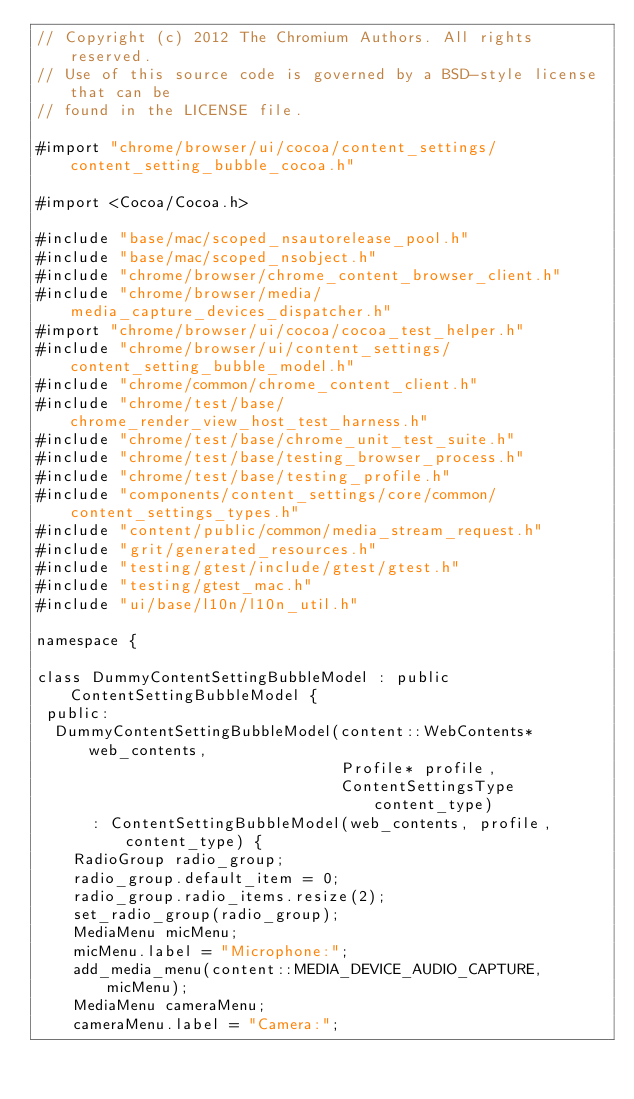<code> <loc_0><loc_0><loc_500><loc_500><_ObjectiveC_>// Copyright (c) 2012 The Chromium Authors. All rights reserved.
// Use of this source code is governed by a BSD-style license that can be
// found in the LICENSE file.

#import "chrome/browser/ui/cocoa/content_settings/content_setting_bubble_cocoa.h"

#import <Cocoa/Cocoa.h>

#include "base/mac/scoped_nsautorelease_pool.h"
#include "base/mac/scoped_nsobject.h"
#include "chrome/browser/chrome_content_browser_client.h"
#include "chrome/browser/media/media_capture_devices_dispatcher.h"
#import "chrome/browser/ui/cocoa/cocoa_test_helper.h"
#include "chrome/browser/ui/content_settings/content_setting_bubble_model.h"
#include "chrome/common/chrome_content_client.h"
#include "chrome/test/base/chrome_render_view_host_test_harness.h"
#include "chrome/test/base/chrome_unit_test_suite.h"
#include "chrome/test/base/testing_browser_process.h"
#include "chrome/test/base/testing_profile.h"
#include "components/content_settings/core/common/content_settings_types.h"
#include "content/public/common/media_stream_request.h"
#include "grit/generated_resources.h"
#include "testing/gtest/include/gtest/gtest.h"
#include "testing/gtest_mac.h"
#include "ui/base/l10n/l10n_util.h"

namespace {

class DummyContentSettingBubbleModel : public ContentSettingBubbleModel {
 public:
  DummyContentSettingBubbleModel(content::WebContents* web_contents,
                                 Profile* profile,
                                 ContentSettingsType content_type)
      : ContentSettingBubbleModel(web_contents, profile, content_type) {
    RadioGroup radio_group;
    radio_group.default_item = 0;
    radio_group.radio_items.resize(2);
    set_radio_group(radio_group);
    MediaMenu micMenu;
    micMenu.label = "Microphone:";
    add_media_menu(content::MEDIA_DEVICE_AUDIO_CAPTURE, micMenu);
    MediaMenu cameraMenu;
    cameraMenu.label = "Camera:";</code> 